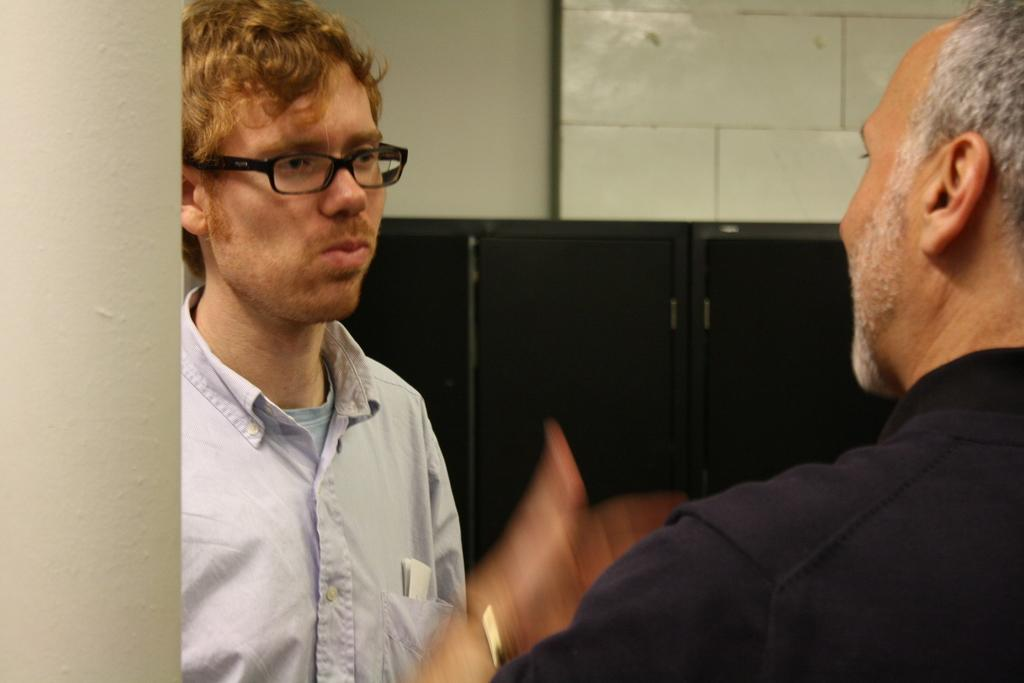How many people are in the image? There are two men in the image. Can you describe the appearance of one of the men? The man on the left side is wearing spectacles. What can be seen in the background of the image? There is a wall in the background of the image. Are the two men engaged in a fight in the image? No, there is no indication of a fight in the image; the two men are simply standing there. 